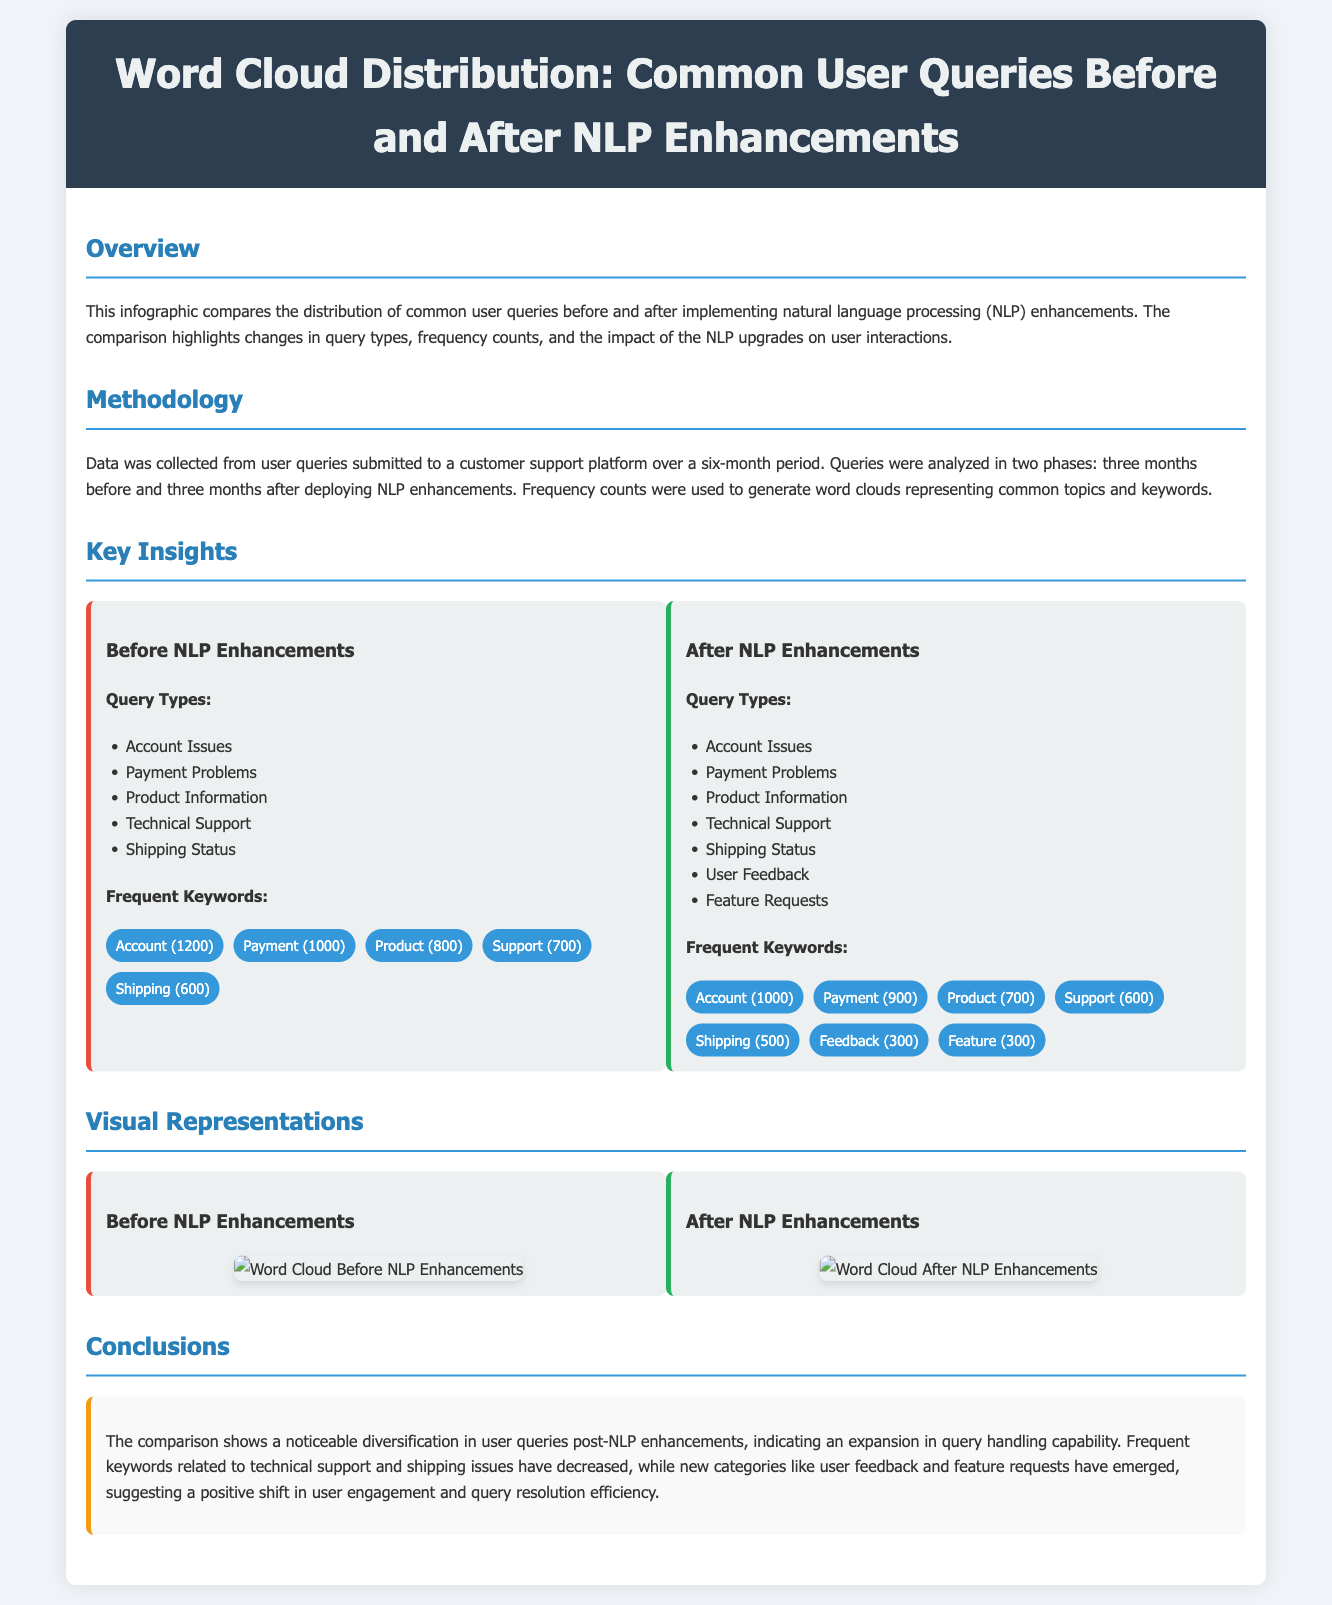What was the main focus of the infographic? The infographic compares the distribution of common user queries before and after NLP enhancements, highlighting changes in query types and frequency counts.
Answer: User queries comparison What was the total number of "Account" queries before NLP enhancements? The document states that the frequency count for "Account" queries before NLP enhancements was 1200.
Answer: 1200 What new query types emerged after NLP enhancements? The document lists "User Feedback" and "Feature Requests" as new query types after the enhancements.
Answer: User Feedback, Feature Requests How many total query types were listed after NLP enhancements? After NLP enhancements, there are seven types of queries listed, indicating an increase from the previous number.
Answer: 7 What keyword frequency count decreased the most after enhancements? The document indicates that the frequency of "Account" queries decreased from 1200 to 1000 after the enhancements.
Answer: 200 Which keyword was introduced after NLP enhancements and what was its frequency? "Feedback" was introduced after NLP enhancements with a frequency count of 300.
Answer: Feedback (300) What was the purpose of the methodology section? The methodology section explains how the data was collected, analyzed, and utilized to generate word clouds representing common topics.
Answer: Data collection and analysis What visual representation does the infographic contain? The infographic includes word clouds before and after NLP enhancements as visual representations of user queries.
Answer: Word clouds What conclusion can be drawn regarding user engagement from the document? The conclusions section states that there is a positive shift in user engagement indicated by diversification in user queries.
Answer: Positive shift in engagement 